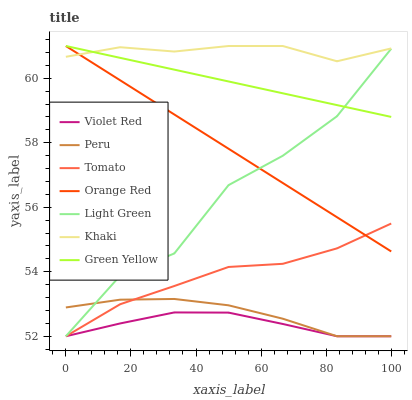Does Khaki have the minimum area under the curve?
Answer yes or no. No. Does Violet Red have the maximum area under the curve?
Answer yes or no. No. Is Violet Red the smoothest?
Answer yes or no. No. Is Violet Red the roughest?
Answer yes or no. No. Does Khaki have the lowest value?
Answer yes or no. No. Does Violet Red have the highest value?
Answer yes or no. No. Is Peru less than Orange Red?
Answer yes or no. Yes. Is Khaki greater than Peru?
Answer yes or no. Yes. Does Peru intersect Orange Red?
Answer yes or no. No. 